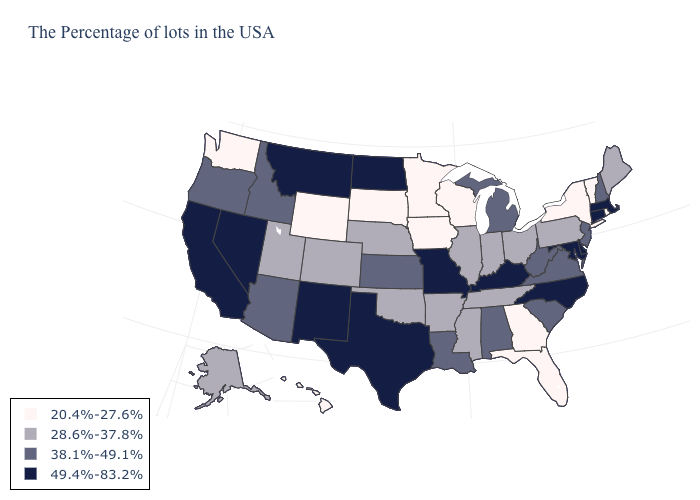What is the highest value in the USA?
Answer briefly. 49.4%-83.2%. What is the value of Virginia?
Keep it brief. 38.1%-49.1%. Does Ohio have a lower value than North Dakota?
Quick response, please. Yes. Name the states that have a value in the range 20.4%-27.6%?
Answer briefly. Rhode Island, Vermont, New York, Florida, Georgia, Wisconsin, Minnesota, Iowa, South Dakota, Wyoming, Washington, Hawaii. Does Arkansas have the highest value in the South?
Short answer required. No. Name the states that have a value in the range 28.6%-37.8%?
Give a very brief answer. Maine, Pennsylvania, Ohio, Indiana, Tennessee, Illinois, Mississippi, Arkansas, Nebraska, Oklahoma, Colorado, Utah, Alaska. Name the states that have a value in the range 20.4%-27.6%?
Quick response, please. Rhode Island, Vermont, New York, Florida, Georgia, Wisconsin, Minnesota, Iowa, South Dakota, Wyoming, Washington, Hawaii. Which states have the lowest value in the USA?
Concise answer only. Rhode Island, Vermont, New York, Florida, Georgia, Wisconsin, Minnesota, Iowa, South Dakota, Wyoming, Washington, Hawaii. Name the states that have a value in the range 49.4%-83.2%?
Quick response, please. Massachusetts, Connecticut, Delaware, Maryland, North Carolina, Kentucky, Missouri, Texas, North Dakota, New Mexico, Montana, Nevada, California. Which states hav the highest value in the MidWest?
Short answer required. Missouri, North Dakota. Which states have the highest value in the USA?
Keep it brief. Massachusetts, Connecticut, Delaware, Maryland, North Carolina, Kentucky, Missouri, Texas, North Dakota, New Mexico, Montana, Nevada, California. Does Kansas have a lower value than Florida?
Give a very brief answer. No. What is the lowest value in the USA?
Give a very brief answer. 20.4%-27.6%. Name the states that have a value in the range 20.4%-27.6%?
Give a very brief answer. Rhode Island, Vermont, New York, Florida, Georgia, Wisconsin, Minnesota, Iowa, South Dakota, Wyoming, Washington, Hawaii. Among the states that border Iowa , which have the highest value?
Quick response, please. Missouri. 